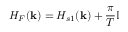Convert formula to latex. <formula><loc_0><loc_0><loc_500><loc_500>H _ { F } ( { k } ) = H _ { s 1 } ( { k } ) + \frac { \pi } { T } \mathbb { I }</formula> 